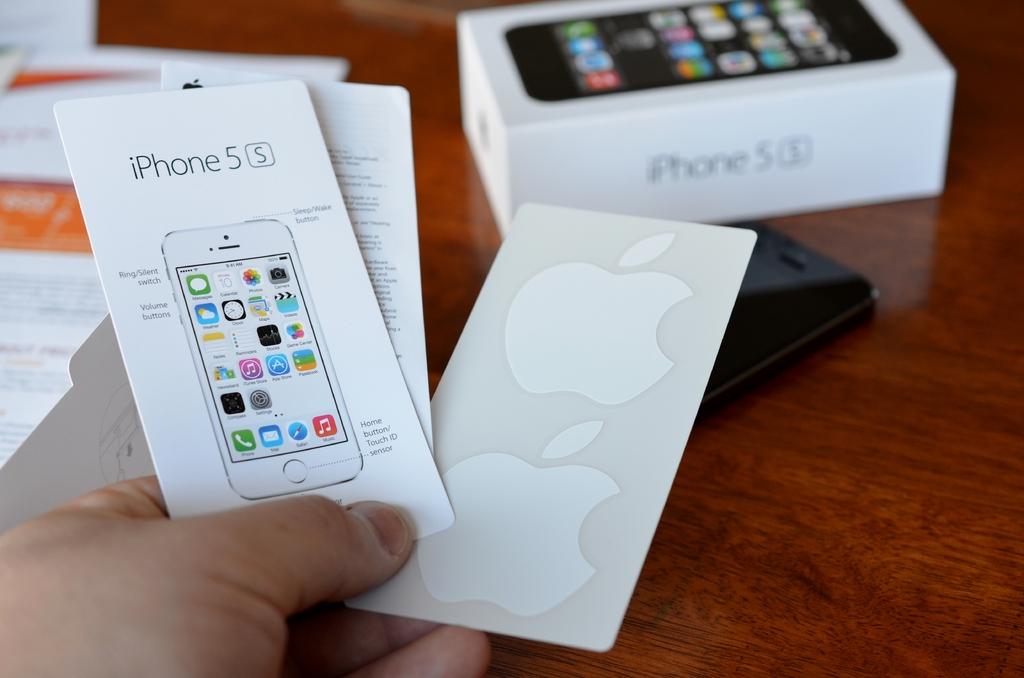Is this booklet about an iphone?
Ensure brevity in your answer.  Yes. What model is this iphone?
Provide a short and direct response. Iphone 5s. 